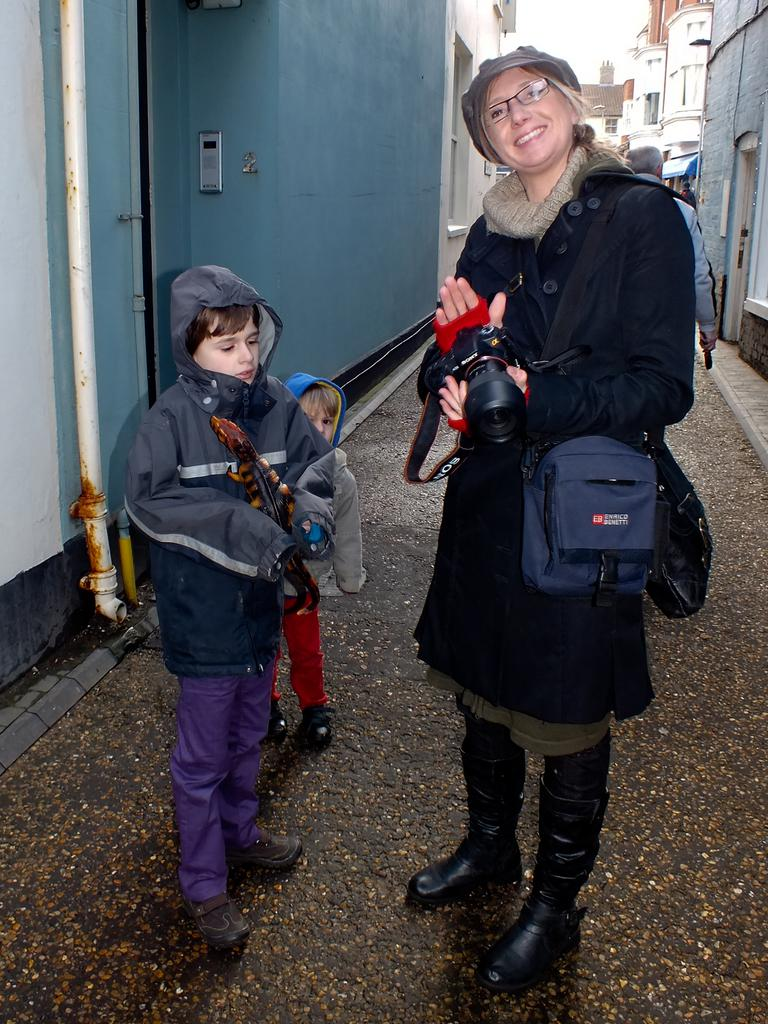What are the people in the image doing? The people in the image are standing on the road. Can you describe what the woman is holding in her hand? The woman is holding a camera in her hand. How much money is the woman holding in her hand? The woman is not holding money in her hand; she is holding a camera. What type of card is being used by the people in the image? There is no card visible in the image; the woman is holding a camera. 